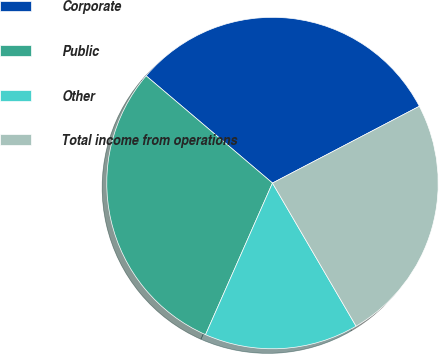<chart> <loc_0><loc_0><loc_500><loc_500><pie_chart><fcel>Corporate<fcel>Public<fcel>Other<fcel>Total income from operations<nl><fcel>31.13%<fcel>29.58%<fcel>15.03%<fcel>24.25%<nl></chart> 